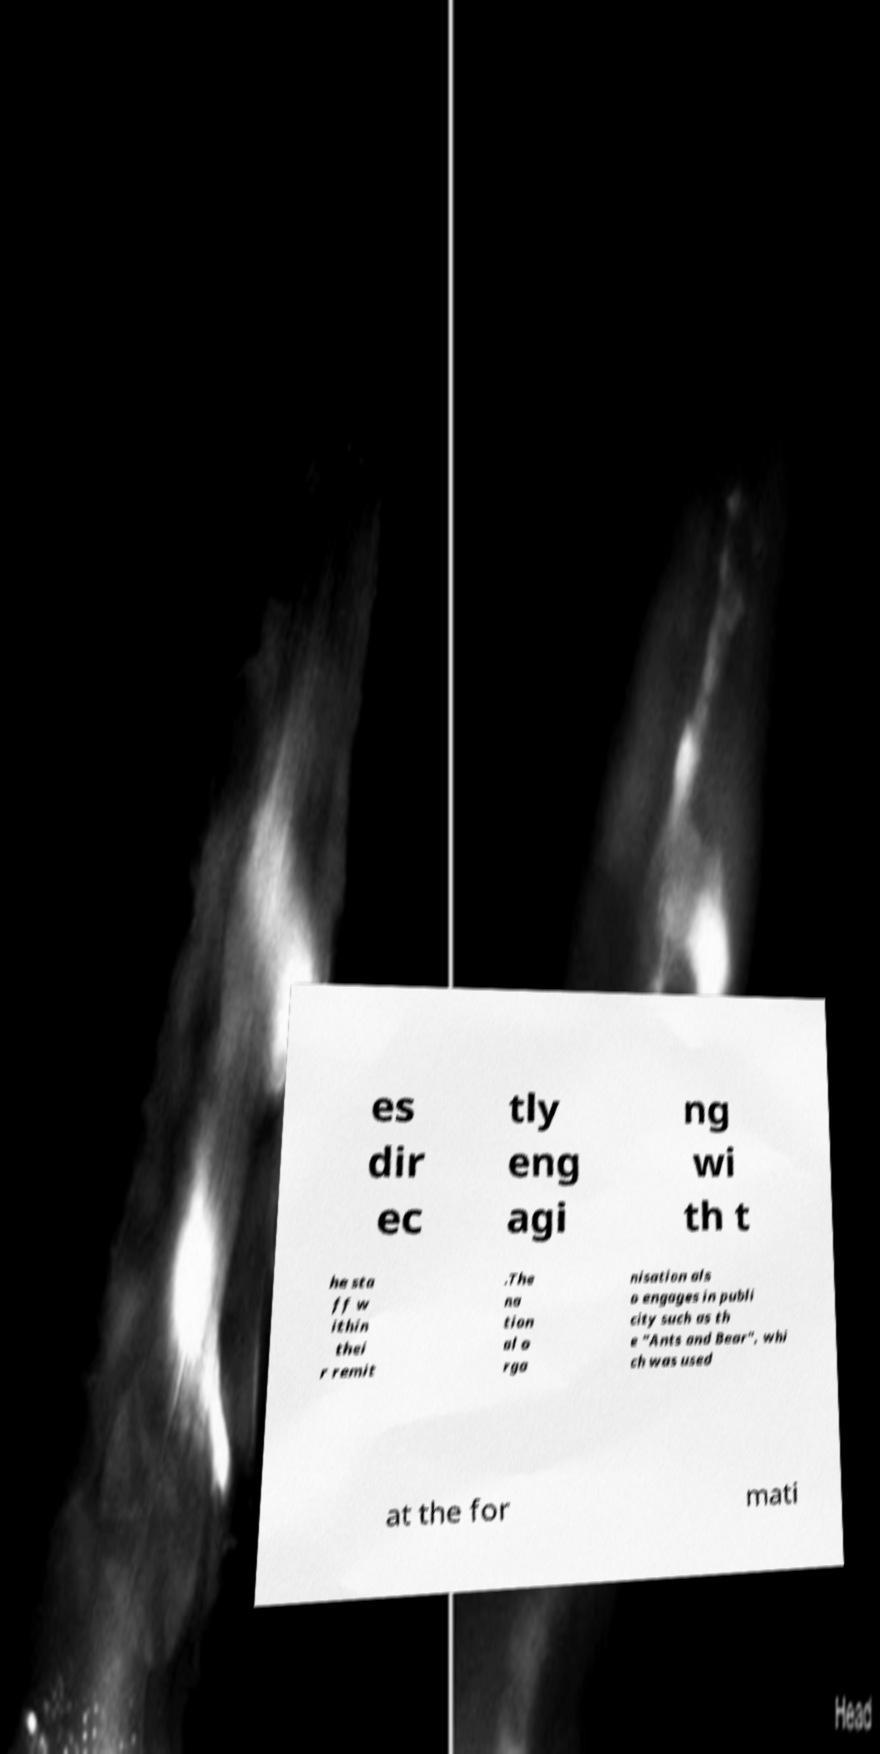Please read and relay the text visible in this image. What does it say? es dir ec tly eng agi ng wi th t he sta ff w ithin thei r remit .The na tion al o rga nisation als o engages in publi city such as th e "Ants and Bear", whi ch was used at the for mati 